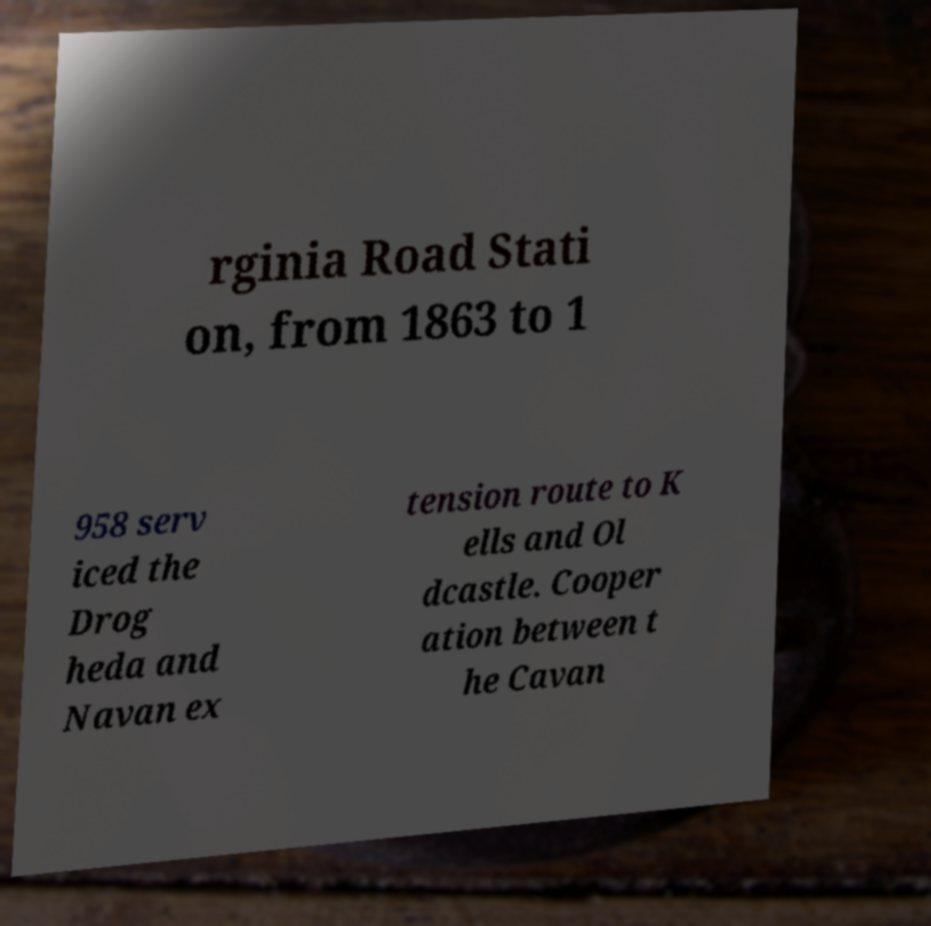For documentation purposes, I need the text within this image transcribed. Could you provide that? rginia Road Stati on, from 1863 to 1 958 serv iced the Drog heda and Navan ex tension route to K ells and Ol dcastle. Cooper ation between t he Cavan 